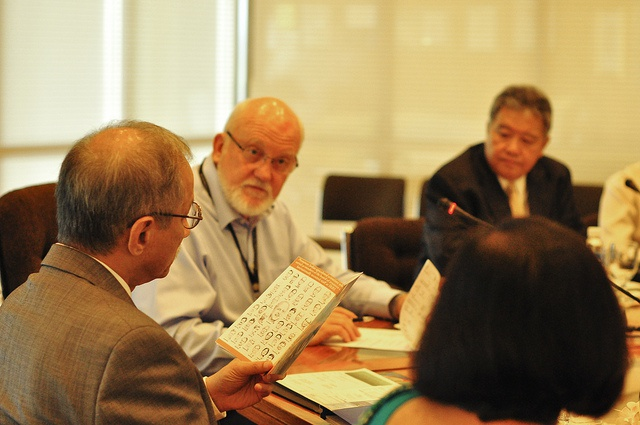Describe the objects in this image and their specific colors. I can see people in tan, brown, maroon, and black tones, people in tan, black, maroon, brown, and orange tones, people in tan and red tones, people in tan, black, brown, and maroon tones, and book in tan, khaki, and olive tones in this image. 